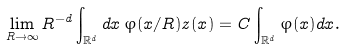<formula> <loc_0><loc_0><loc_500><loc_500>\lim _ { R \rightarrow \infty } R ^ { - d } \int _ { \mathbb { R } ^ { d } } d x \, \varphi ( x / R ) z ( x ) = C \int _ { \mathbb { R } ^ { d } } \varphi ( x ) d x .</formula> 